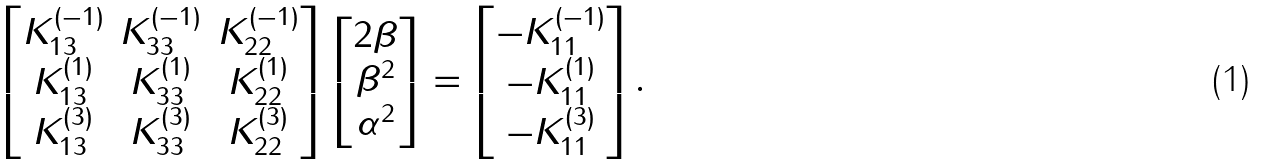Convert formula to latex. <formula><loc_0><loc_0><loc_500><loc_500>\begin{bmatrix} K _ { 1 3 } ^ { ( - 1 ) } & K _ { 3 3 } ^ { ( - 1 ) } & K _ { 2 2 } ^ { ( - 1 ) } \\ K _ { 1 3 } ^ { ( 1 ) } & K _ { 3 3 } ^ { ( 1 ) } & K _ { 2 2 } ^ { ( 1 ) } \\ K _ { 1 3 } ^ { ( 3 ) } & K _ { 3 3 } ^ { ( 3 ) } & K _ { 2 2 } ^ { ( 3 ) } \end{bmatrix} \begin{bmatrix} 2 \beta \\ \beta ^ { 2 } \\ \alpha ^ { 2 } \end{bmatrix} = \begin{bmatrix} - K _ { 1 1 } ^ { ( - 1 ) } \\ - K _ { 1 1 } ^ { ( 1 ) } \\ - K _ { 1 1 } ^ { ( 3 ) } \end{bmatrix} .</formula> 